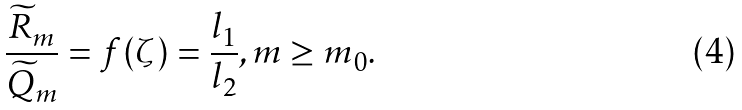Convert formula to latex. <formula><loc_0><loc_0><loc_500><loc_500>\frac { \widetilde { R } _ { m } } { \widetilde { Q } _ { m } } = f ( \zeta ) = \frac { l _ { 1 } } { l _ { 2 } } , m \geq m _ { 0 } .</formula> 